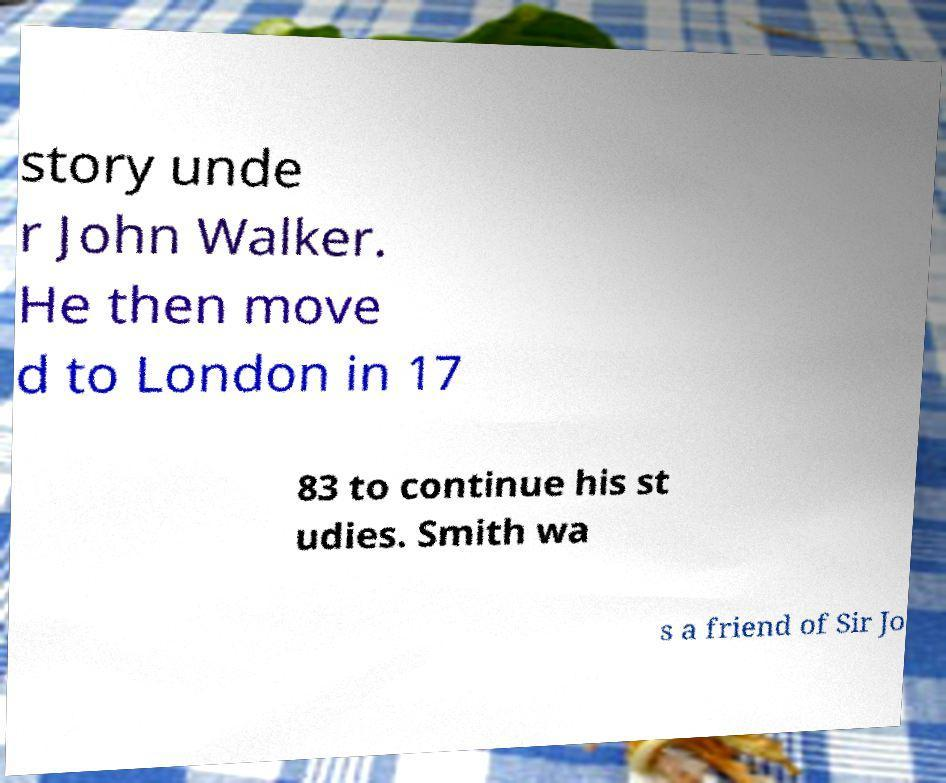I need the written content from this picture converted into text. Can you do that? story unde r John Walker. He then move d to London in 17 83 to continue his st udies. Smith wa s a friend of Sir Jo 